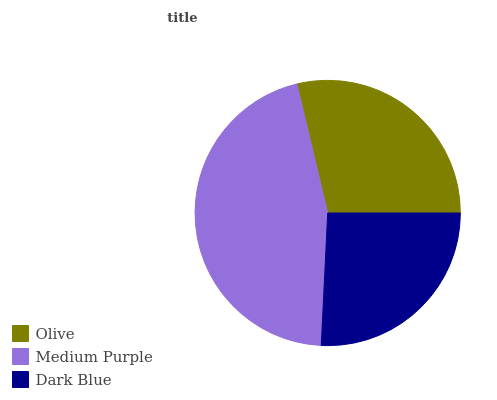Is Dark Blue the minimum?
Answer yes or no. Yes. Is Medium Purple the maximum?
Answer yes or no. Yes. Is Medium Purple the minimum?
Answer yes or no. No. Is Dark Blue the maximum?
Answer yes or no. No. Is Medium Purple greater than Dark Blue?
Answer yes or no. Yes. Is Dark Blue less than Medium Purple?
Answer yes or no. Yes. Is Dark Blue greater than Medium Purple?
Answer yes or no. No. Is Medium Purple less than Dark Blue?
Answer yes or no. No. Is Olive the high median?
Answer yes or no. Yes. Is Olive the low median?
Answer yes or no. Yes. Is Dark Blue the high median?
Answer yes or no. No. Is Dark Blue the low median?
Answer yes or no. No. 